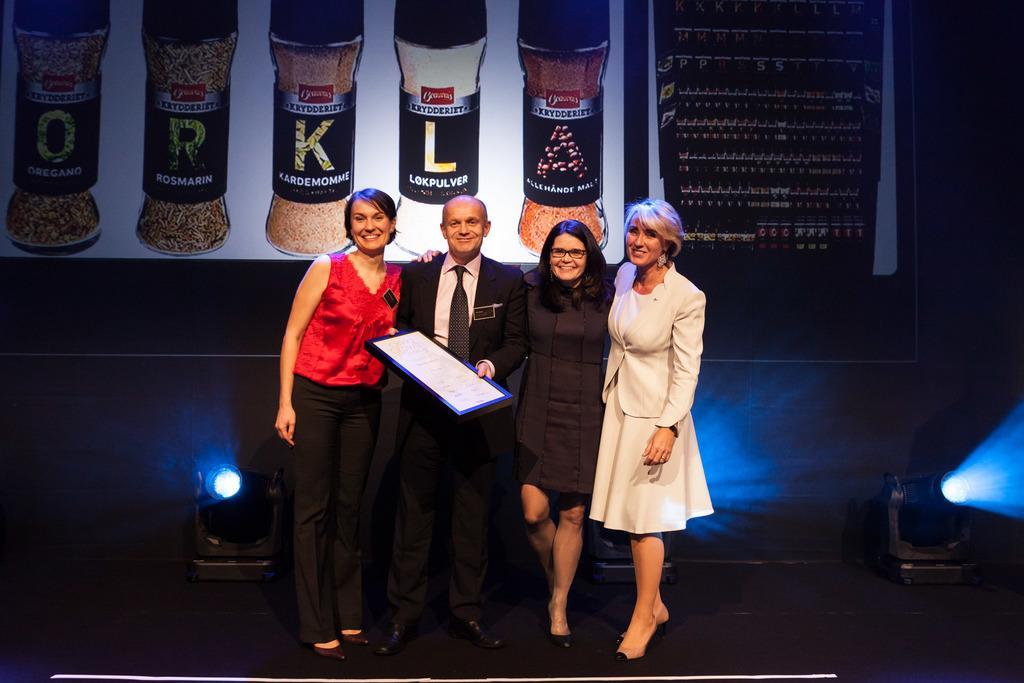Can you describe this image briefly? There are people standing and smiling and he is holding a frame. We can see focusing lights. In the background we can see banner and it is dark. 